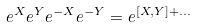<formula> <loc_0><loc_0><loc_500><loc_500>e ^ { X } e ^ { Y } e ^ { - X } e ^ { - Y } = e ^ { [ X , Y ] + \dots }</formula> 